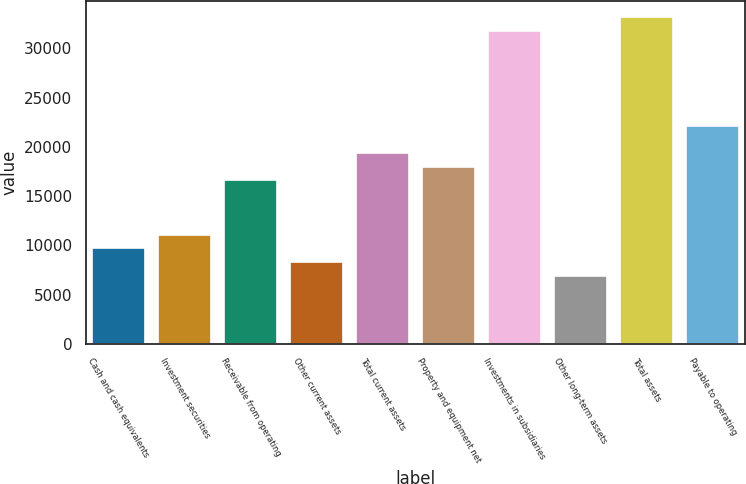<chart> <loc_0><loc_0><loc_500><loc_500><bar_chart><fcel>Cash and cash equivalents<fcel>Investment securities<fcel>Receivable from operating<fcel>Other current assets<fcel>Total current assets<fcel>Property and equipment net<fcel>Investments in subsidiaries<fcel>Other long-term assets<fcel>Total assets<fcel>Payable to operating<nl><fcel>9682.58<fcel>11065.4<fcel>16596.7<fcel>8299.76<fcel>19362.3<fcel>17979.5<fcel>31807.7<fcel>6916.94<fcel>33190.5<fcel>22128<nl></chart> 